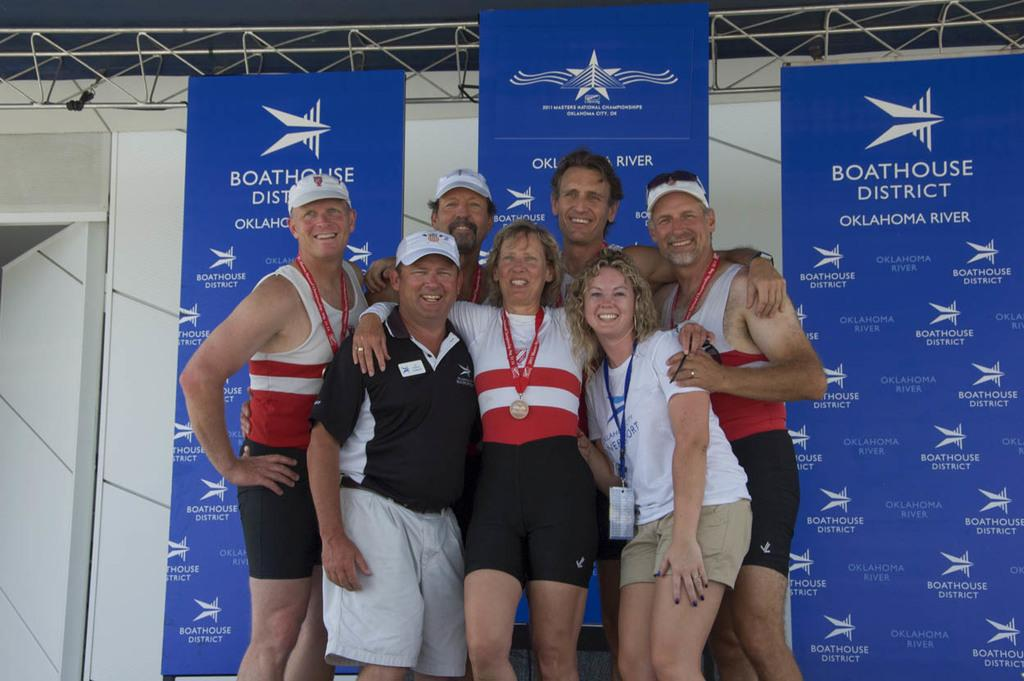<image>
Summarize the visual content of the image. People posing for a photo in front of a banner which says "Boathouse District". 